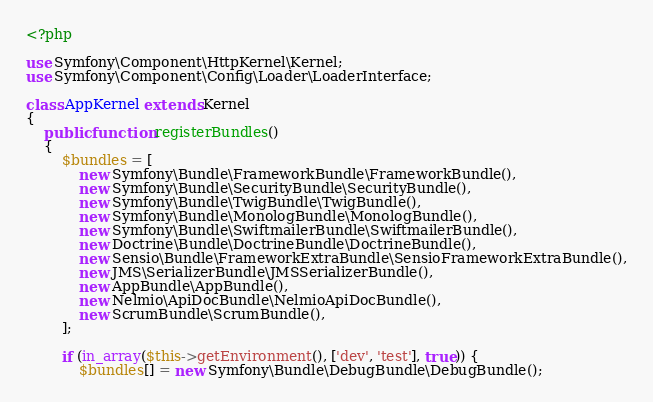Convert code to text. <code><loc_0><loc_0><loc_500><loc_500><_PHP_><?php

use Symfony\Component\HttpKernel\Kernel;
use Symfony\Component\Config\Loader\LoaderInterface;

class AppKernel extends Kernel
{
    public function registerBundles()
    {
        $bundles = [
            new Symfony\Bundle\FrameworkBundle\FrameworkBundle(),
            new Symfony\Bundle\SecurityBundle\SecurityBundle(),
            new Symfony\Bundle\TwigBundle\TwigBundle(),
            new Symfony\Bundle\MonologBundle\MonologBundle(),
            new Symfony\Bundle\SwiftmailerBundle\SwiftmailerBundle(),
            new Doctrine\Bundle\DoctrineBundle\DoctrineBundle(),
            new Sensio\Bundle\FrameworkExtraBundle\SensioFrameworkExtraBundle(),
            new JMS\SerializerBundle\JMSSerializerBundle(),
            new AppBundle\AppBundle(),
            new Nelmio\ApiDocBundle\NelmioApiDocBundle(),
            new ScrumBundle\ScrumBundle(),
        ];

        if (in_array($this->getEnvironment(), ['dev', 'test'], true)) {
            $bundles[] = new Symfony\Bundle\DebugBundle\DebugBundle();</code> 